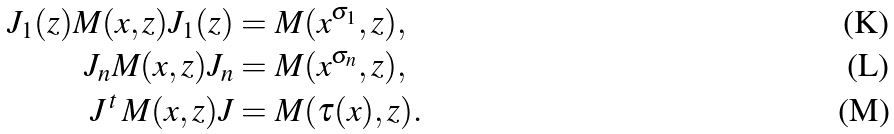Convert formula to latex. <formula><loc_0><loc_0><loc_500><loc_500>J _ { 1 } ( z ) M ( x , z ) J _ { 1 } ( z ) & = M ( x ^ { \sigma _ { 1 } } , z ) , \\ J _ { n } M ( x , z ) J _ { n } & = M ( x ^ { \sigma _ { n } } , z ) , \\ J \, ^ { t } \, M ( x , z ) J & = M ( \tau ( x ) , z ) .</formula> 